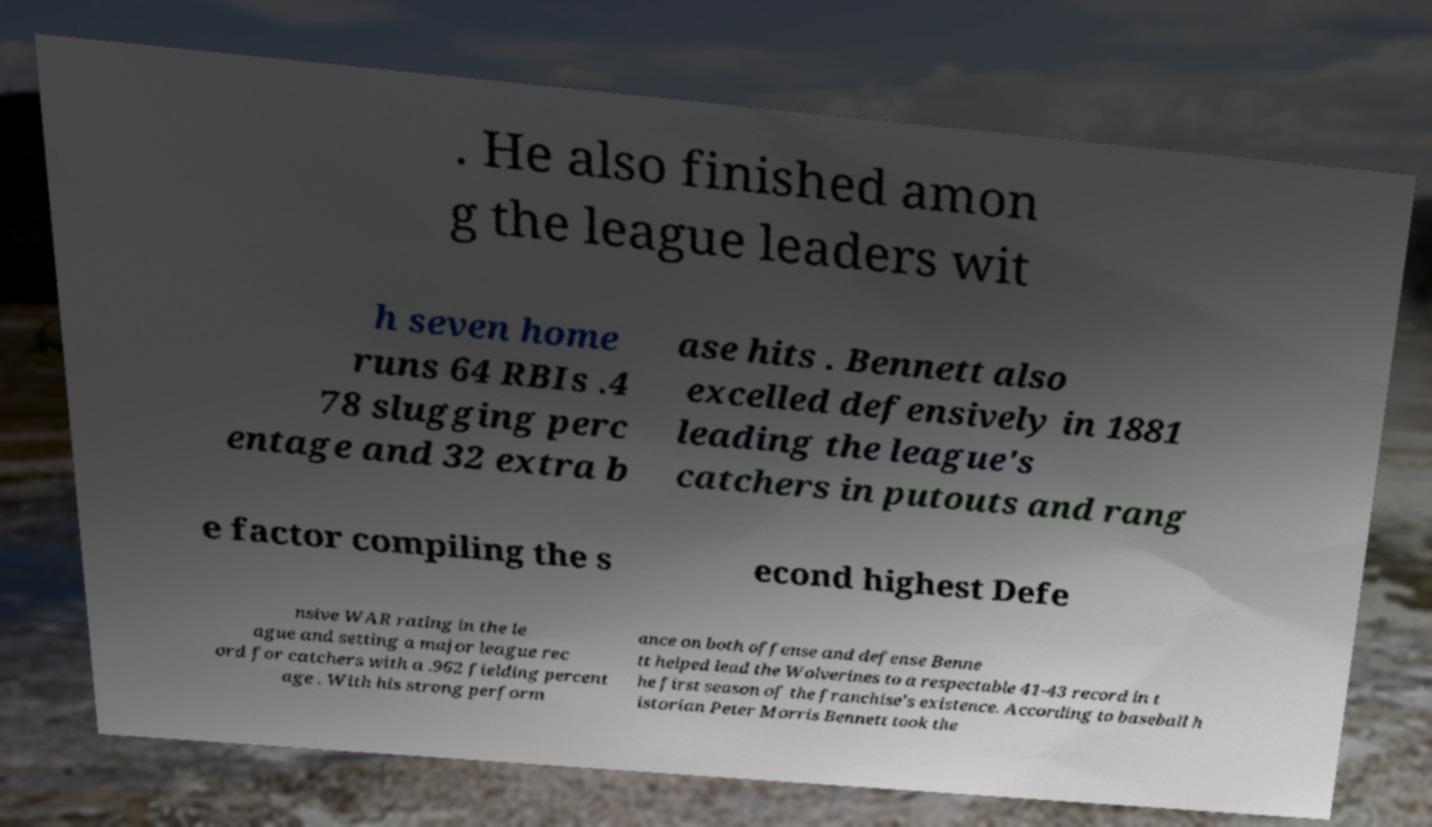What messages or text are displayed in this image? I need them in a readable, typed format. . He also finished amon g the league leaders wit h seven home runs 64 RBIs .4 78 slugging perc entage and 32 extra b ase hits . Bennett also excelled defensively in 1881 leading the league's catchers in putouts and rang e factor compiling the s econd highest Defe nsive WAR rating in the le ague and setting a major league rec ord for catchers with a .962 fielding percent age . With his strong perform ance on both offense and defense Benne tt helped lead the Wolverines to a respectable 41-43 record in t he first season of the franchise's existence. According to baseball h istorian Peter Morris Bennett took the 